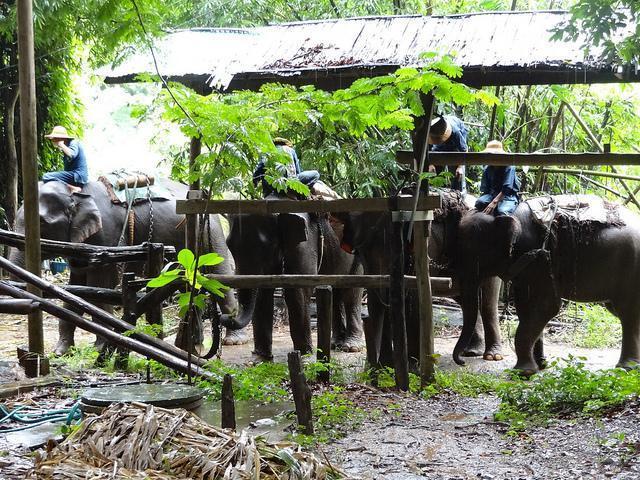How many elephants are there?
Give a very brief answer. 4. 